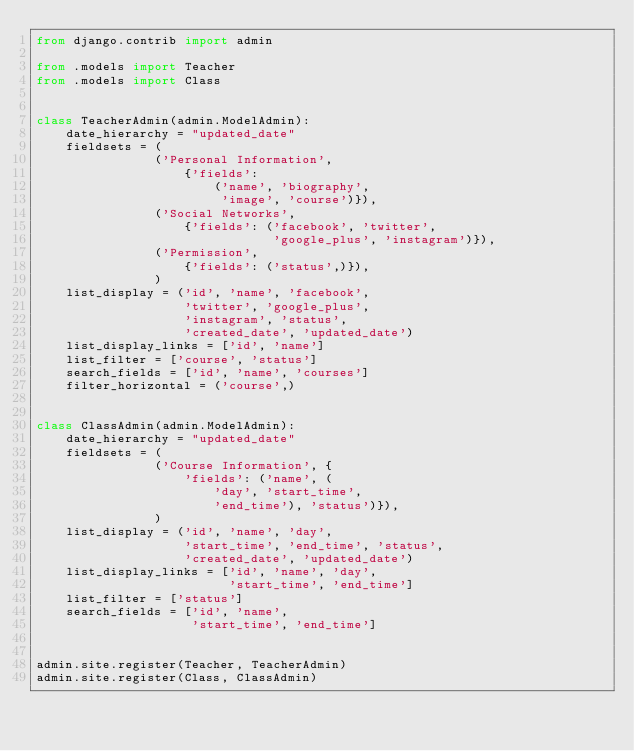Convert code to text. <code><loc_0><loc_0><loc_500><loc_500><_Python_>from django.contrib import admin

from .models import Teacher
from .models import Class


class TeacherAdmin(admin.ModelAdmin):
    date_hierarchy = "updated_date"
    fieldsets = (
                ('Personal Information',
                    {'fields':
                        ('name', 'biography',
                         'image', 'course')}),
                ('Social Networks',
                    {'fields': ('facebook', 'twitter',
                                'google_plus', 'instagram')}),
                ('Permission',
                    {'fields': ('status',)}),
                )
    list_display = ('id', 'name', 'facebook',
                    'twitter', 'google_plus',
                    'instagram', 'status',
                    'created_date', 'updated_date')
    list_display_links = ['id', 'name']
    list_filter = ['course', 'status']
    search_fields = ['id', 'name', 'courses']
    filter_horizontal = ('course',)


class ClassAdmin(admin.ModelAdmin):
    date_hierarchy = "updated_date"
    fieldsets = (
                ('Course Information', {
                    'fields': ('name', (
                        'day', 'start_time',
                        'end_time'), 'status')}),
                )
    list_display = ('id', 'name', 'day',
                    'start_time', 'end_time', 'status',
                    'created_date', 'updated_date')
    list_display_links = ['id', 'name', 'day',
                          'start_time', 'end_time']
    list_filter = ['status']
    search_fields = ['id', 'name',
                     'start_time', 'end_time']


admin.site.register(Teacher, TeacherAdmin)
admin.site.register(Class, ClassAdmin)
</code> 